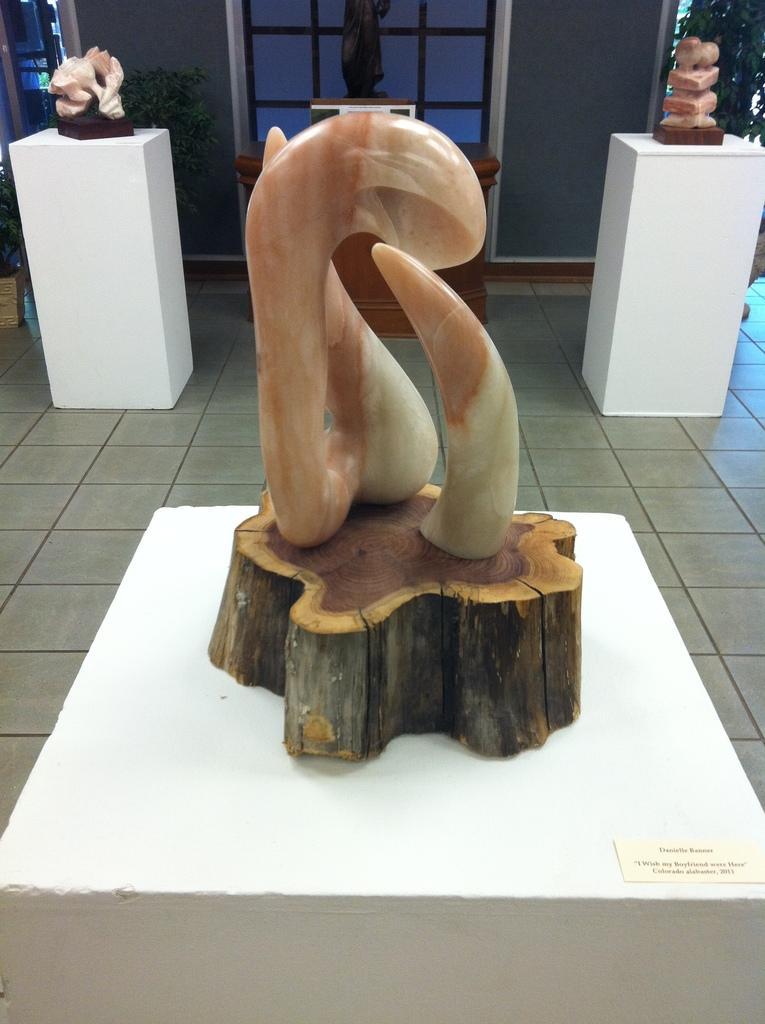How would you summarize this image in a sentence or two? In the center of the image there is a table. On table we can see a wood trunk is present. On wood trunk a sculpture is there. In the background of the image we can see the plants and wall are there. In the middle of the image floor is present. 